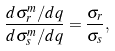Convert formula to latex. <formula><loc_0><loc_0><loc_500><loc_500>\frac { d \sigma _ { r } ^ { m } / d q } { d \sigma _ { s } ^ { m } / d q } = \frac { \sigma _ { r } } { \sigma _ { s } } ,</formula> 